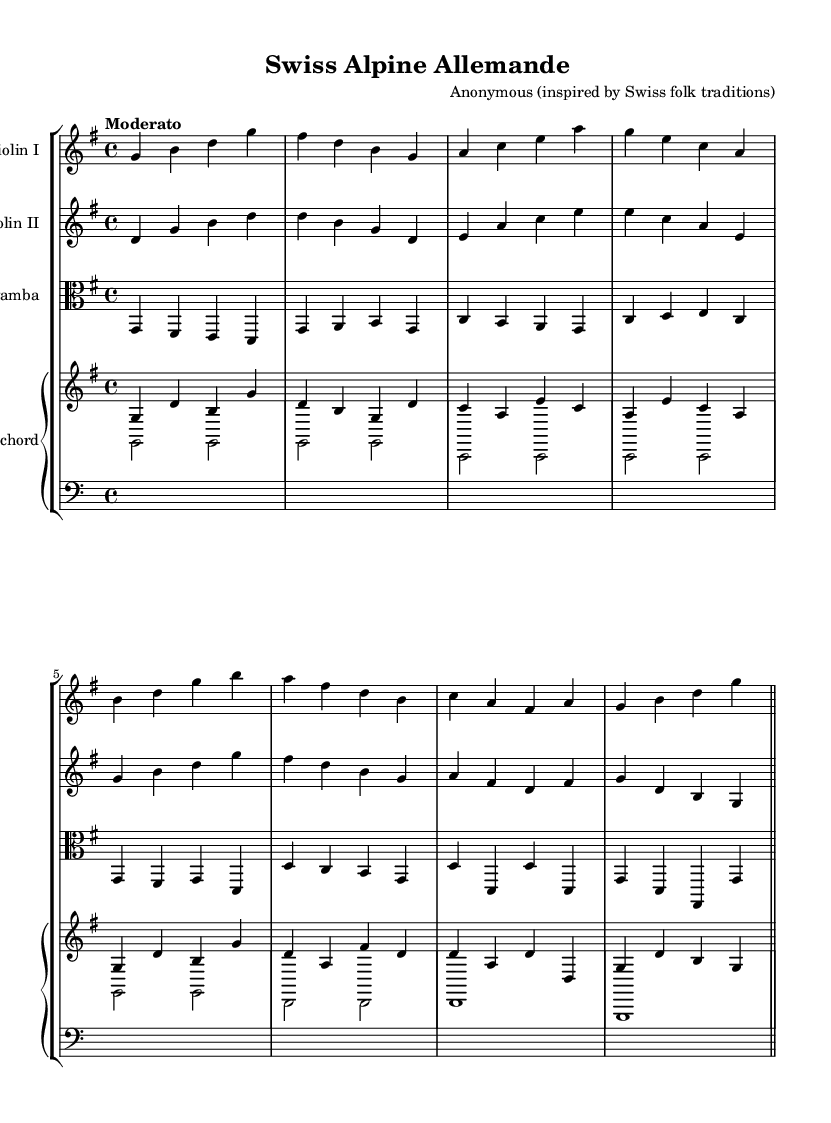What is the key signature of this music? The key signature is G major, which has one sharp (F sharp). This can be determined by examining the key signature at the beginning of the score.
Answer: G major What is the time signature of the first measure? The time signature is 4/4, indicated at the beginning of the score. This tells us that there are four beats in each measure and a quarter note gets one beat.
Answer: 4/4 What tempo marking is indicated for this piece? The tempo marking indicates "Moderato," which describes a moderate pace for the performance. This can be found in the section that outlines tempo at the beginning of the piece.
Answer: Moderato How many staves are used for the violin parts? There are two staves for the violins, one for Violin I and one for Violin II. Each staff contains its own set of notes, showing that there are two separate parts being played simultaneously.
Answer: Two Which instrument plays the harmonies in this score? The harpsichord plays the harmonies, as indicated by its placement in the score and the notation showing chord progressions and accompaniment figures.
Answer: Harpsichord What type of dance is represented in this sheet music? The piece represents an Allemande, a type of Baroque dance that is typically moderate in tempo and in a binary form. This can be identified by the title of the piece at the top of the score.
Answer: Allemande How many different instruments are featured in this music? Four different instruments are featured: two violins, a viola da gamba, and a harpsichord. This is evident from the different instrument names listed in the score headers.
Answer: Four 